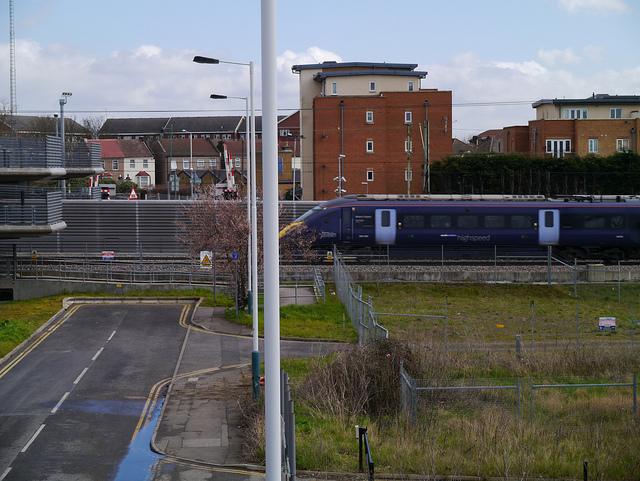What color is the front of the train?
Short answer required. Yellow. How many white lines are on the road?
Concise answer only. 6. What color is the grass?
Be succinct. Green. 